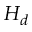<formula> <loc_0><loc_0><loc_500><loc_500>H _ { d }</formula> 